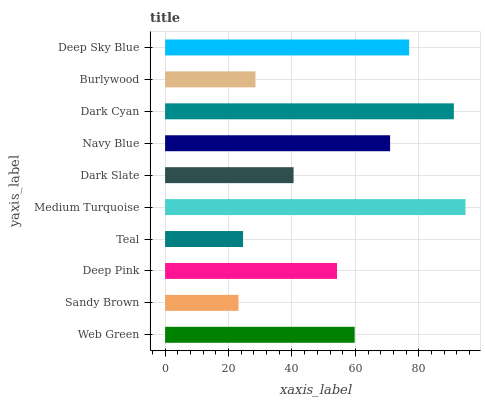Is Sandy Brown the minimum?
Answer yes or no. Yes. Is Medium Turquoise the maximum?
Answer yes or no. Yes. Is Deep Pink the minimum?
Answer yes or no. No. Is Deep Pink the maximum?
Answer yes or no. No. Is Deep Pink greater than Sandy Brown?
Answer yes or no. Yes. Is Sandy Brown less than Deep Pink?
Answer yes or no. Yes. Is Sandy Brown greater than Deep Pink?
Answer yes or no. No. Is Deep Pink less than Sandy Brown?
Answer yes or no. No. Is Web Green the high median?
Answer yes or no. Yes. Is Deep Pink the low median?
Answer yes or no. Yes. Is Navy Blue the high median?
Answer yes or no. No. Is Dark Slate the low median?
Answer yes or no. No. 